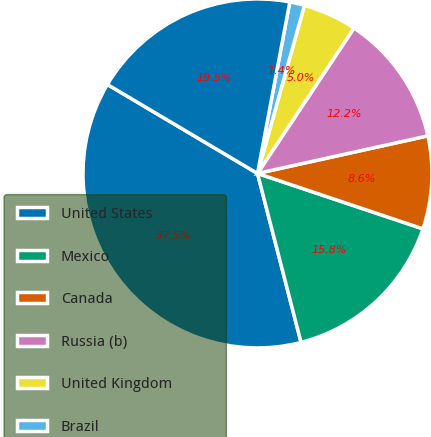Convert chart to OTSL. <chart><loc_0><loc_0><loc_500><loc_500><pie_chart><fcel>United States<fcel>Mexico<fcel>Canada<fcel>Russia (b)<fcel>United Kingdom<fcel>Brazil<fcel>All other countries (c)<nl><fcel>37.53%<fcel>15.84%<fcel>8.6%<fcel>12.22%<fcel>4.99%<fcel>1.37%<fcel>19.45%<nl></chart> 